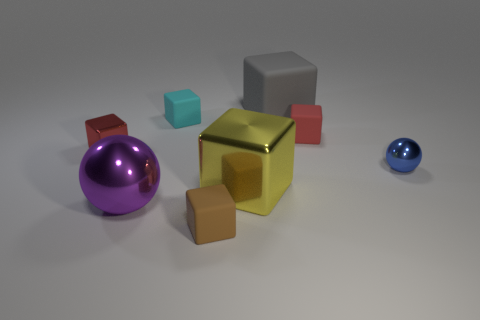Subtract all yellow metal cubes. How many cubes are left? 5 Add 1 tiny red metal cubes. How many objects exist? 9 Subtract all red cubes. How many cubes are left? 4 Subtract all blocks. How many objects are left? 2 Subtract 1 balls. How many balls are left? 1 Subtract all gray spheres. Subtract all purple cubes. How many spheres are left? 2 Subtract all purple cylinders. How many red cubes are left? 2 Subtract all small balls. Subtract all large yellow shiny things. How many objects are left? 6 Add 6 blue objects. How many blue objects are left? 7 Add 2 big metal spheres. How many big metal spheres exist? 3 